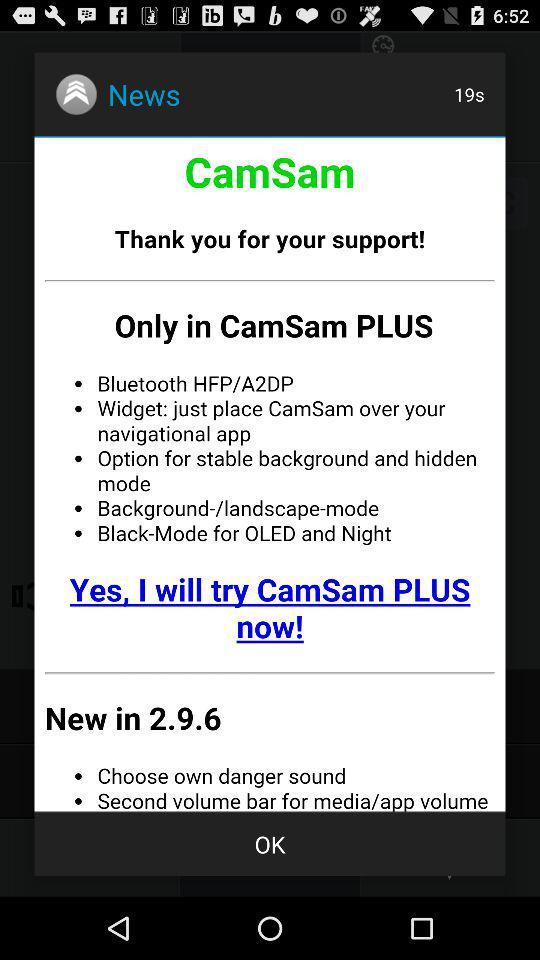What are the features provided in CamSam Plus? The features are "Bluetooth HFP/A2DP", "Widget: just place CamSam over your navigational app", "Option for stable background and hidden mode", "Background-/landscape-mode" and "Black-Mode for OLED and Night". 